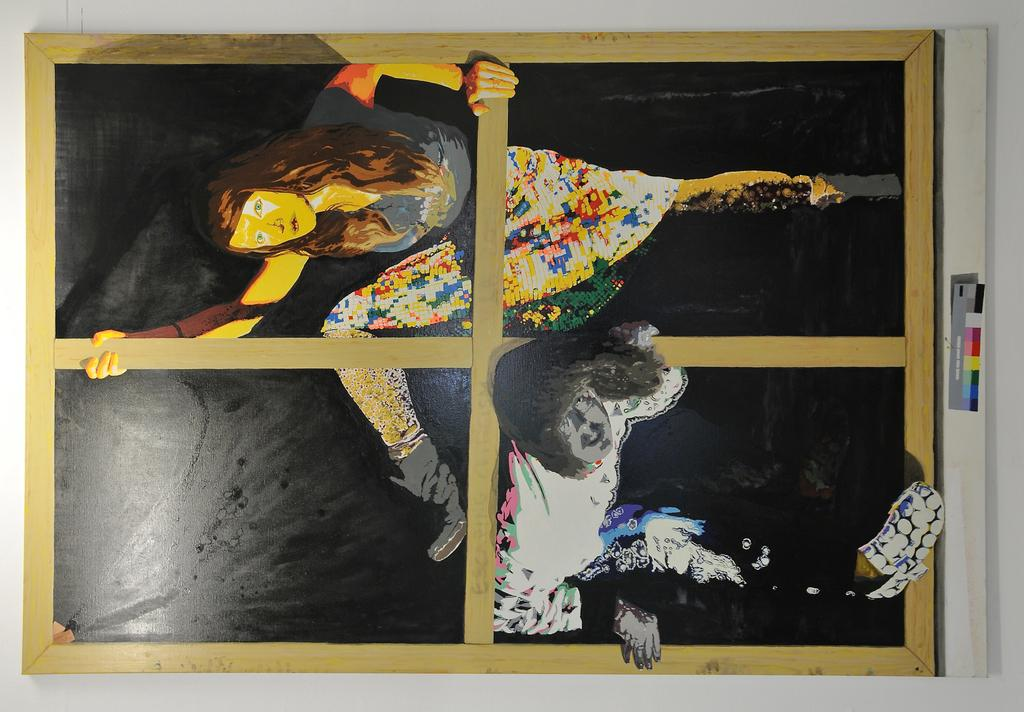What is depicted in the painting that is visible in the image? There is a painting of persons on a board in the image. What else can be seen in the image besides the painting? There is a wall visible in the image. What is the weight of the quilt hanging on the wall in the image? There is no quilt present in the image, so it is not possible to determine its weight. 